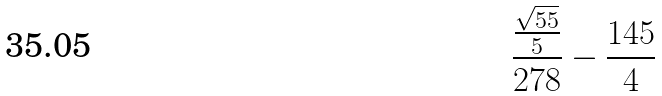<formula> <loc_0><loc_0><loc_500><loc_500>\frac { \frac { \sqrt { 5 5 } } { 5 } } { 2 7 8 } - \frac { 1 4 5 } { 4 }</formula> 